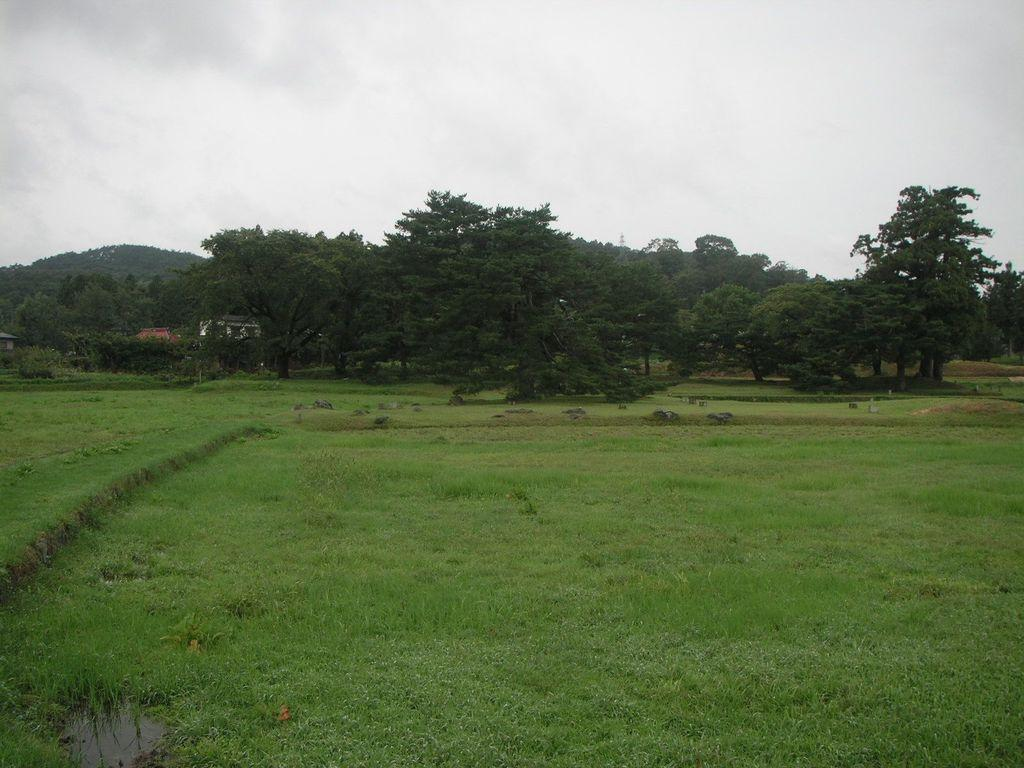What type of vegetation can be seen in the image? There is grass, plants, and trees in the image. What part of the natural environment is visible in the image? The sky is visible in the background of the image. What direction are the plants facing in the image? The direction in which the plants are facing cannot be determined from the image, as they are stationary and not facing any particular direction. 